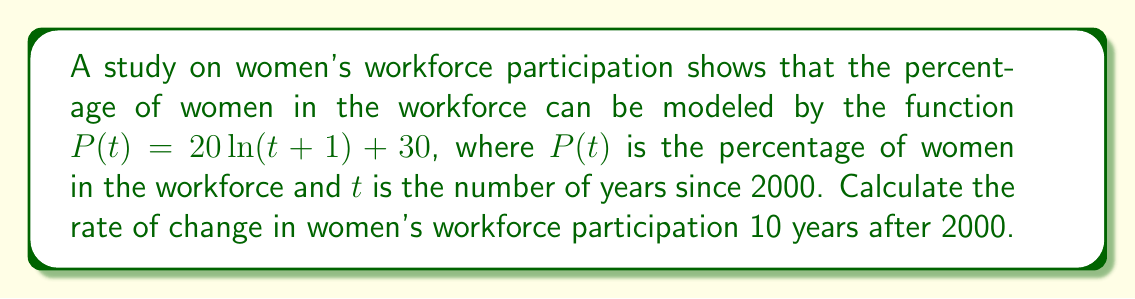Show me your answer to this math problem. To find the rate of change in women's workforce participation, we need to calculate the derivative of the given function and evaluate it at $t = 10$.

Step 1: Given function
$P(t) = 20\ln(t+1) + 30$

Step 2: Calculate the derivative
Using the chain rule:
$$\frac{dP}{dt} = 20 \cdot \frac{d}{dt}[\ln(t+1)] = 20 \cdot \frac{1}{t+1}$$

Step 3: Evaluate the derivative at $t = 10$
$$\frac{dP}{dt}\bigg|_{t=10} = 20 \cdot \frac{1}{10+1} = \frac{20}{11}$$

Step 4: Interpret the result
The rate of change is approximately 1.82 percentage points per year, indicating a positive but slowing growth in women's workforce participation 10 years after 2000.
Answer: $\frac{20}{11}$ percentage points per year 